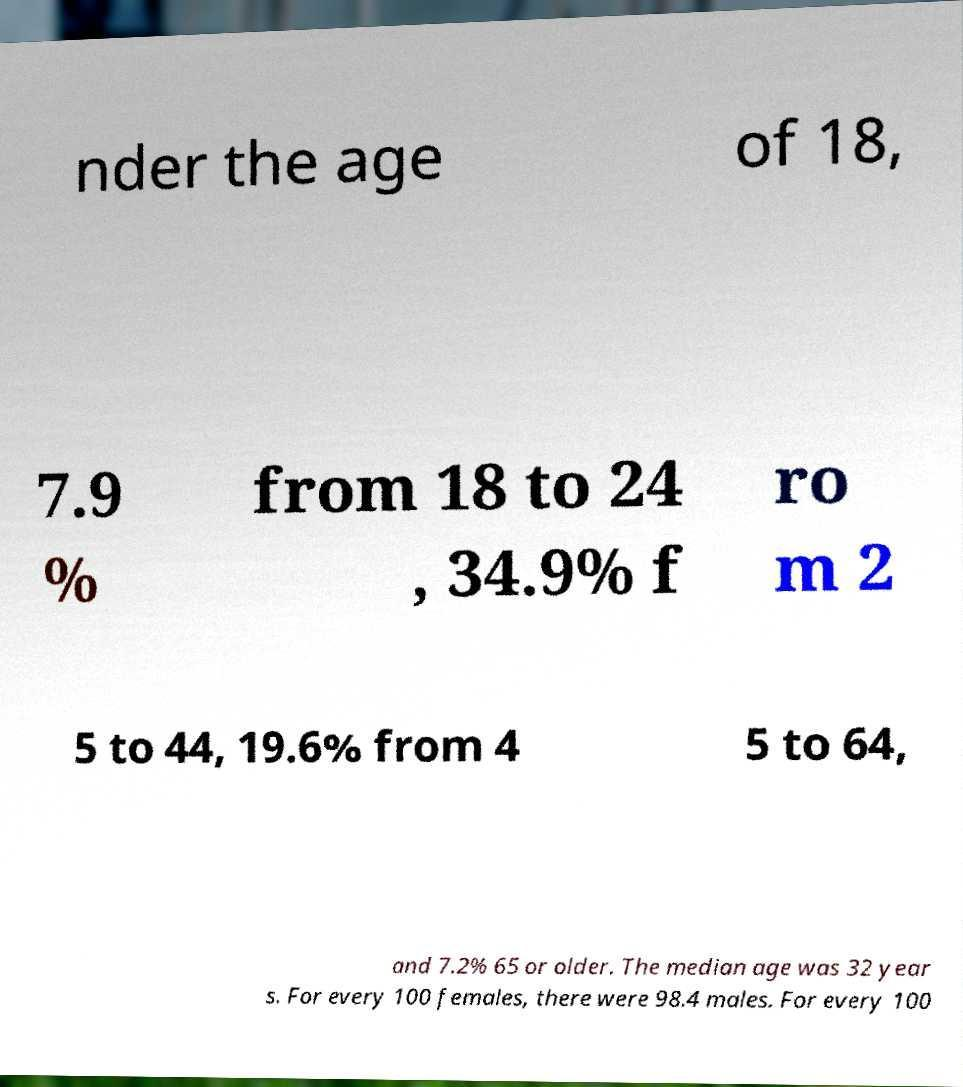Could you assist in decoding the text presented in this image and type it out clearly? nder the age of 18, 7.9 % from 18 to 24 , 34.9% f ro m 2 5 to 44, 19.6% from 4 5 to 64, and 7.2% 65 or older. The median age was 32 year s. For every 100 females, there were 98.4 males. For every 100 